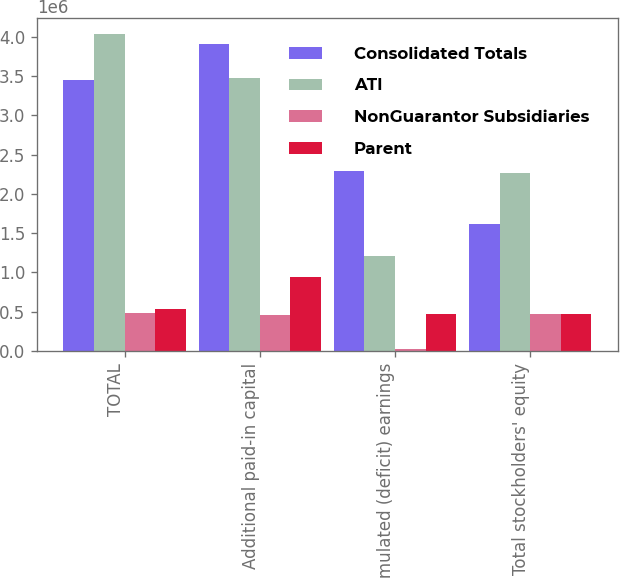Convert chart to OTSL. <chart><loc_0><loc_0><loc_500><loc_500><stacked_bar_chart><ecel><fcel>TOTAL<fcel>Additional paid-in capital<fcel>Accumulated (deficit) earnings<fcel>Total stockholders' equity<nl><fcel>Consolidated Totals<fcel>3.45027e+06<fcel>3.91088e+06<fcel>2.29182e+06<fcel>1.6169e+06<nl><fcel>ATI<fcel>4.0357e+06<fcel>3.47558e+06<fcel>1.20815e+06<fcel>2.26743e+06<nl><fcel>NonGuarantor Subsidiaries<fcel>485875<fcel>453013<fcel>24446<fcel>477459<nl><fcel>Parent<fcel>539418<fcel>946328<fcel>470607<fcel>469001<nl></chart> 